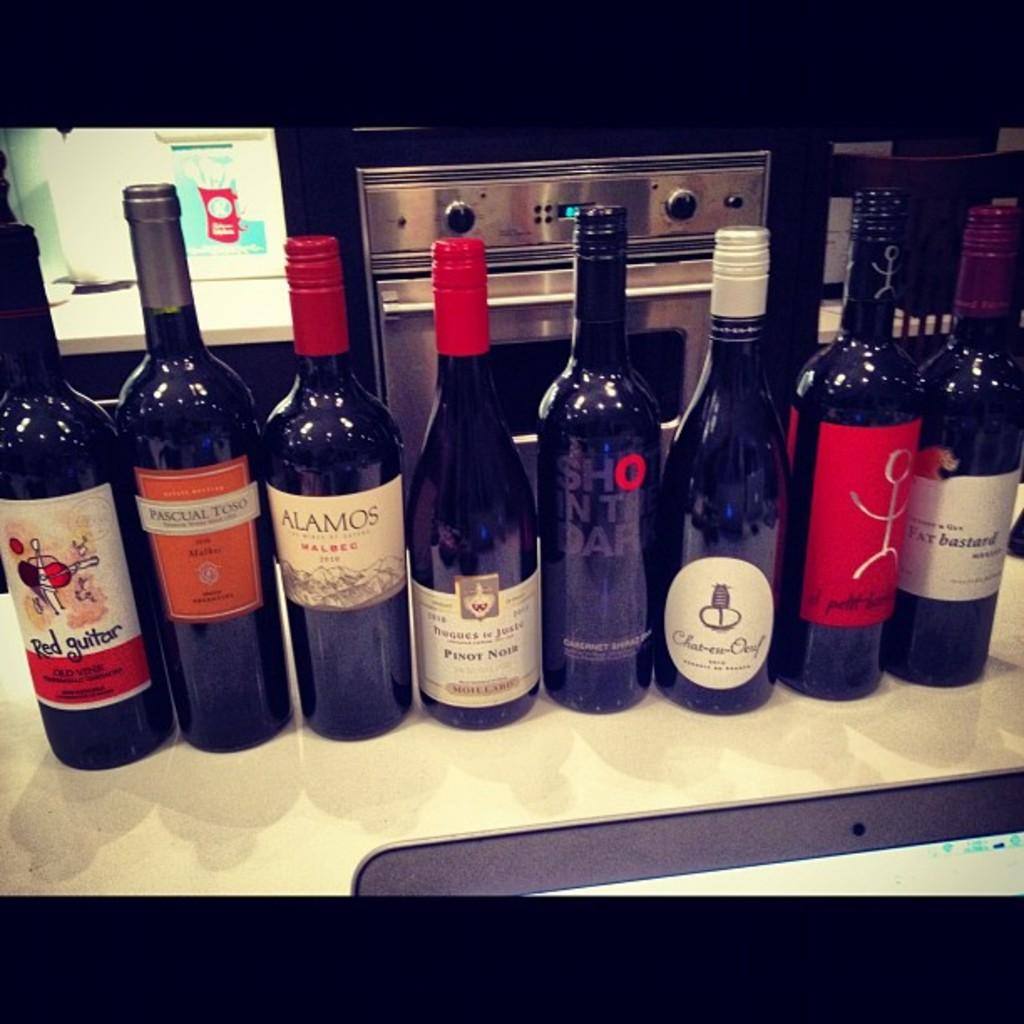<image>
Present a compact description of the photo's key features. Bottles of wine next to one another with one saying "Pinot Noir". 